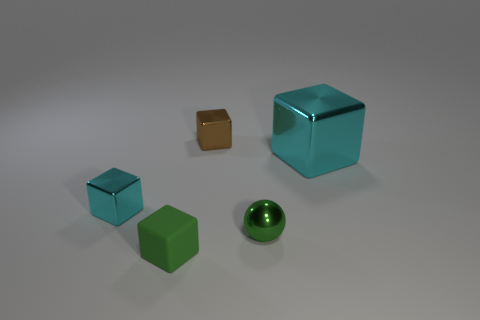Is there anything else that is made of the same material as the green block?
Give a very brief answer. No. Does the small cube in front of the small green sphere have the same color as the small ball?
Your response must be concise. Yes. How many objects are either shiny blocks that are in front of the large cyan object or small blocks that are on the left side of the tiny brown object?
Your response must be concise. 2. What number of small metallic things are in front of the big cyan shiny thing and to the left of the small green shiny object?
Offer a very short reply. 1. Does the green block have the same material as the small brown thing?
Provide a short and direct response. No. There is a green object that is to the right of the tiny cube that is right of the rubber block in front of the tiny brown thing; what is its shape?
Offer a very short reply. Sphere. There is a small cube that is right of the small cyan cube and in front of the brown shiny block; what is it made of?
Your answer should be compact. Rubber. The tiny shiny cube on the right side of the small cyan object that is on the left side of the small metal thing on the right side of the brown block is what color?
Provide a succinct answer. Brown. What number of yellow objects are either big blocks or small cubes?
Give a very brief answer. 0. What number of other objects are there of the same size as the brown metal thing?
Your answer should be compact. 3. 